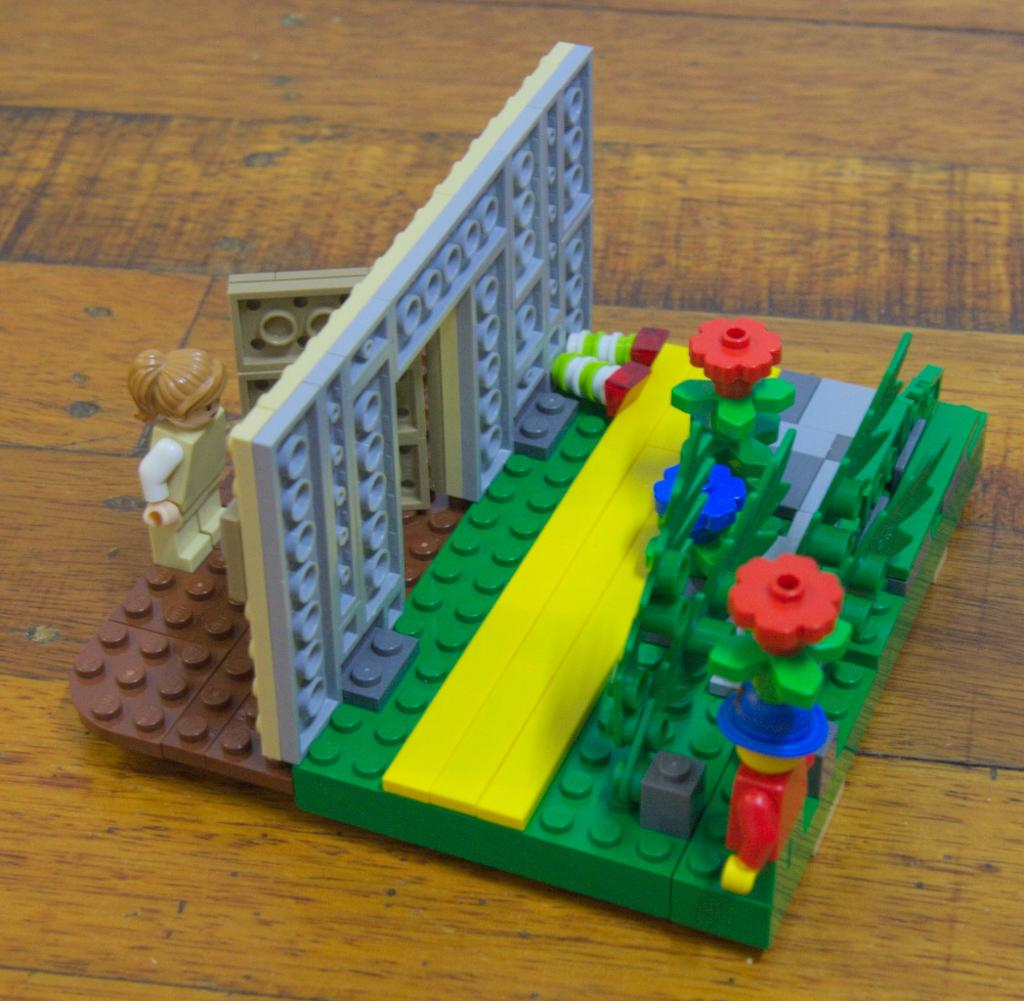What type of items can be seen in the image? There are toys in the image. Are there any other objects present besides the toys? Yes, there are other objects in the image. What type of surface is visible in the image? The wooden surface is present in the image. How many fish are swimming in the water in the image? There is no water or fish present in the image. What type of idea is being expressed in the image? The image does not convey any specific idea; it simply shows toys and other objects on a wooden surface. 